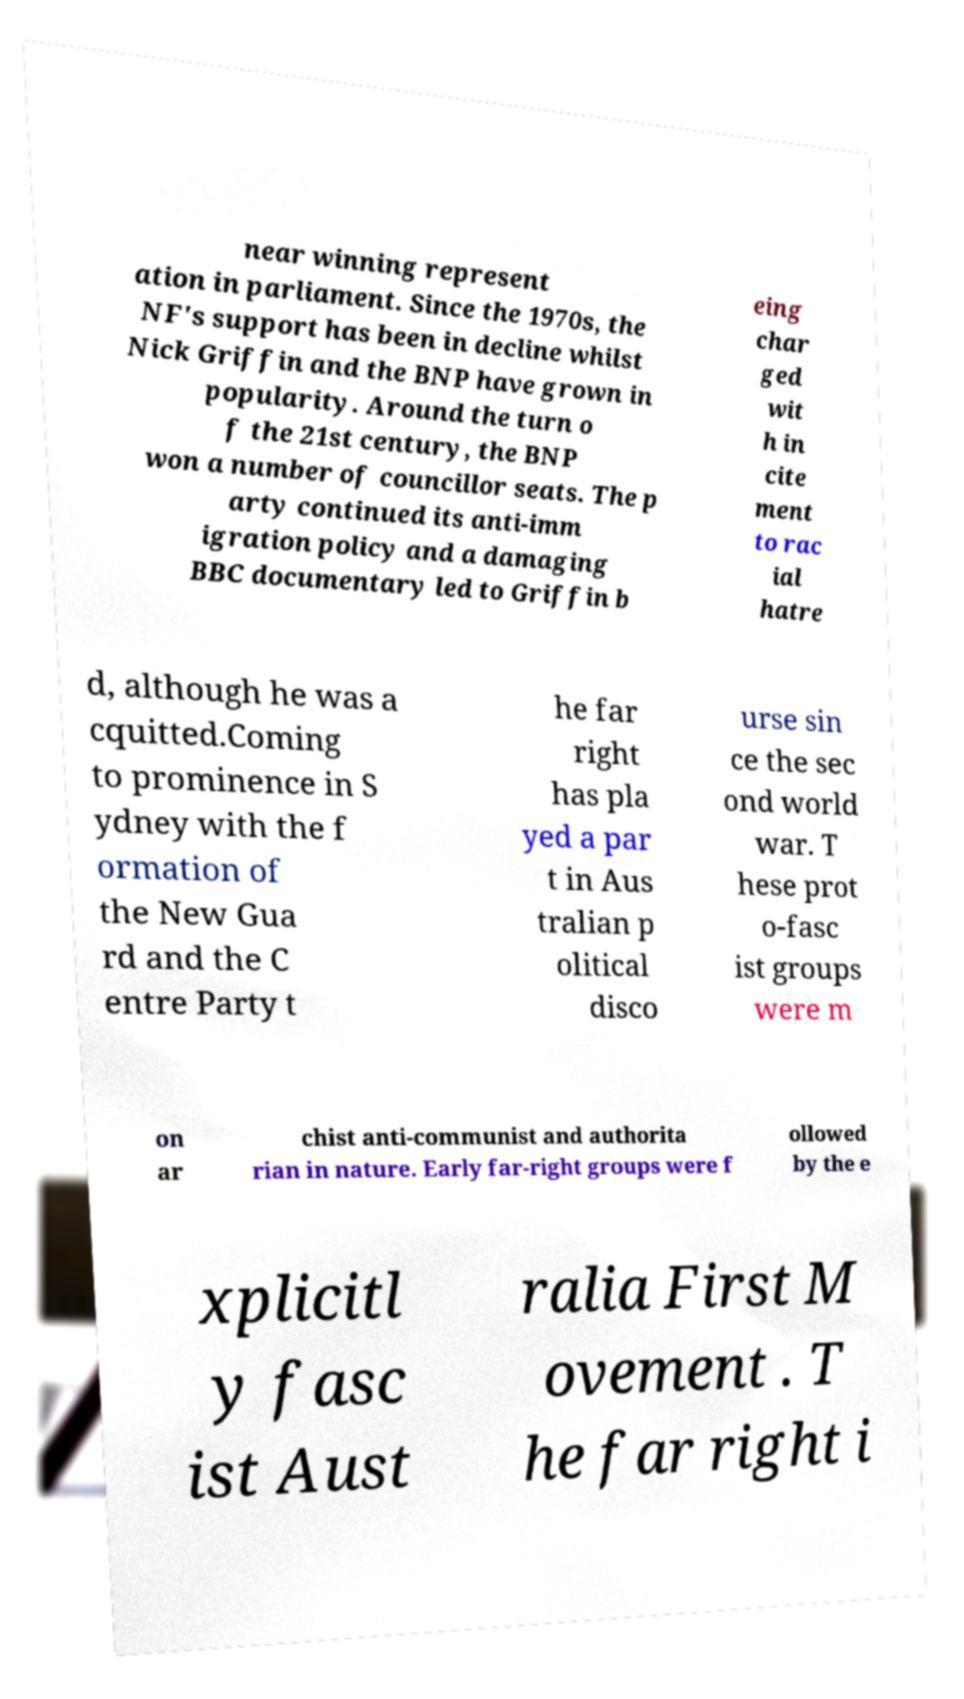Can you accurately transcribe the text from the provided image for me? near winning represent ation in parliament. Since the 1970s, the NF's support has been in decline whilst Nick Griffin and the BNP have grown in popularity. Around the turn o f the 21st century, the BNP won a number of councillor seats. The p arty continued its anti-imm igration policy and a damaging BBC documentary led to Griffin b eing char ged wit h in cite ment to rac ial hatre d, although he was a cquitted.Coming to prominence in S ydney with the f ormation of the New Gua rd and the C entre Party t he far right has pla yed a par t in Aus tralian p olitical disco urse sin ce the sec ond world war. T hese prot o-fasc ist groups were m on ar chist anti-communist and authorita rian in nature. Early far-right groups were f ollowed by the e xplicitl y fasc ist Aust ralia First M ovement . T he far right i 